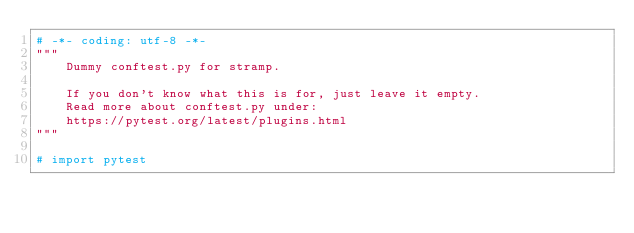<code> <loc_0><loc_0><loc_500><loc_500><_Python_># -*- coding: utf-8 -*-
"""
    Dummy conftest.py for stramp.

    If you don't know what this is for, just leave it empty.
    Read more about conftest.py under:
    https://pytest.org/latest/plugins.html
"""

# import pytest
</code> 